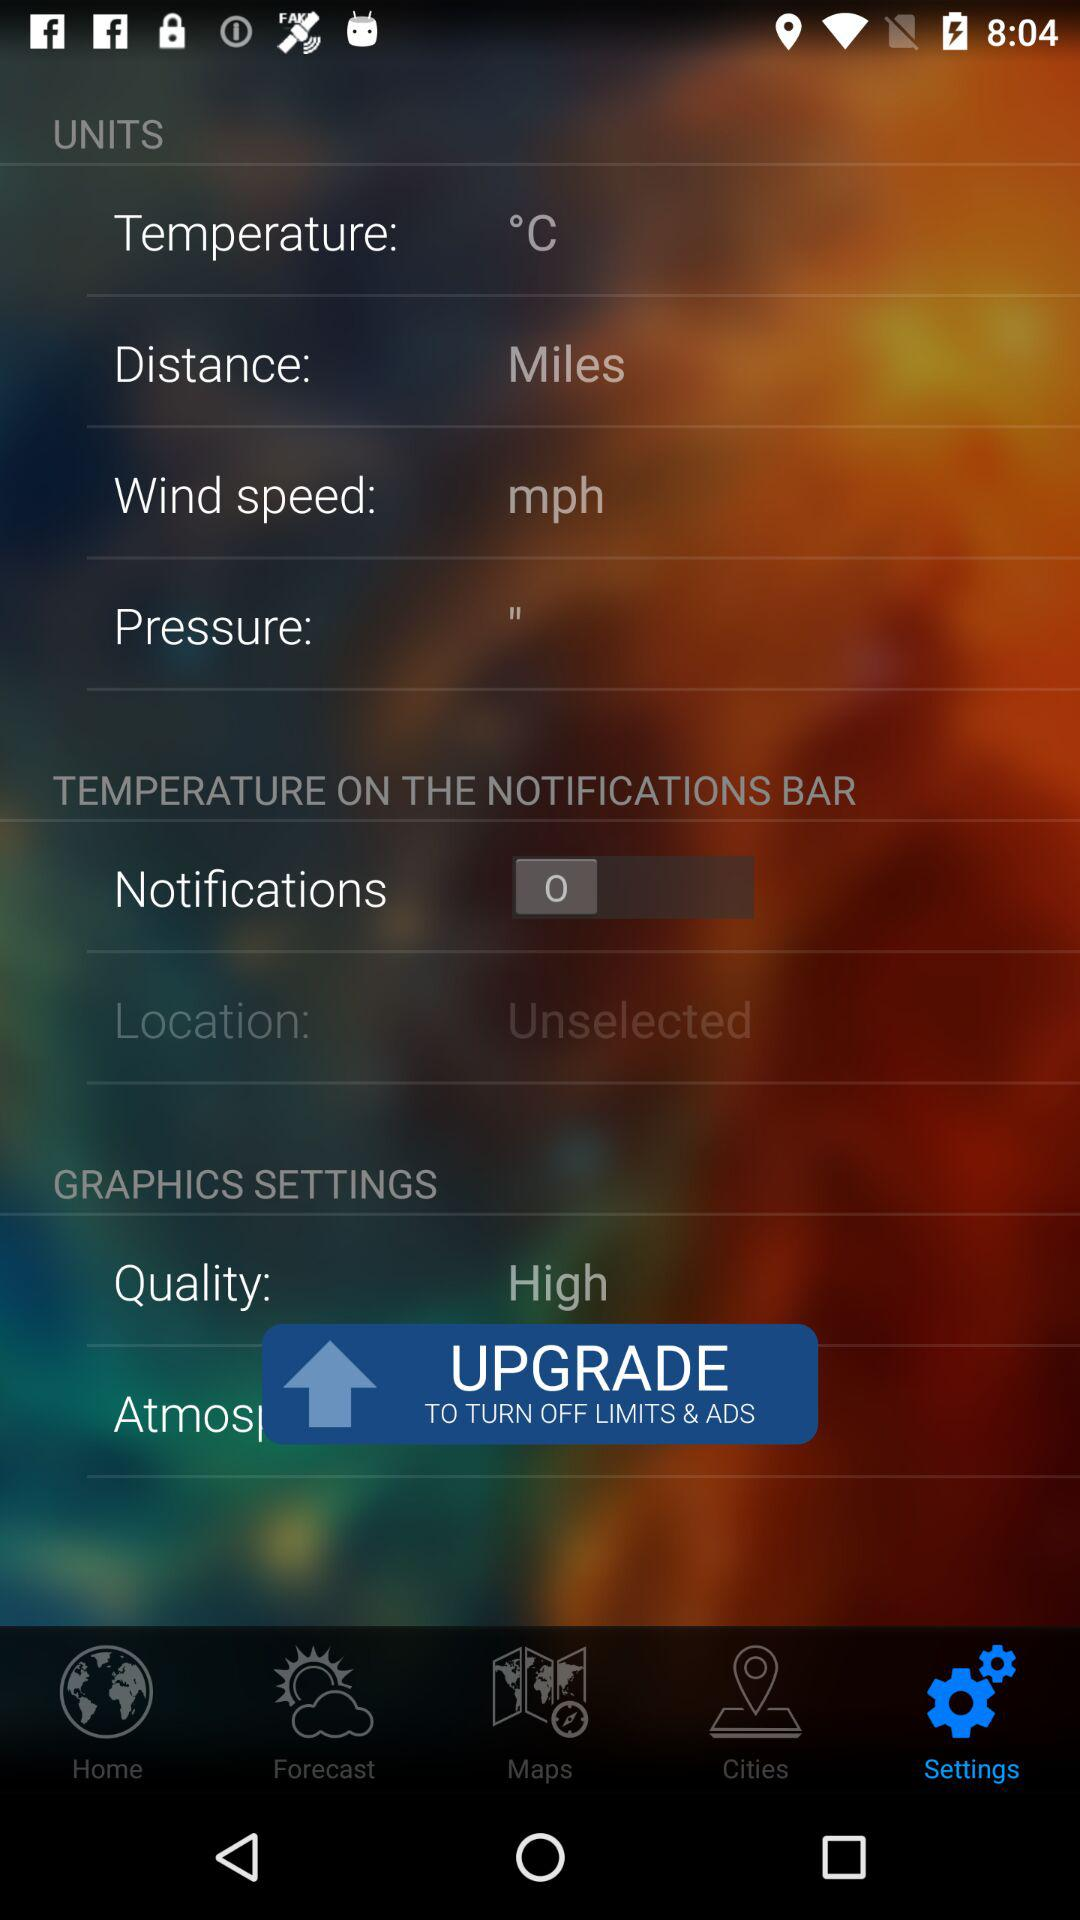Which unit is used to measure the distance? The used unit to measure the distance is miles. 